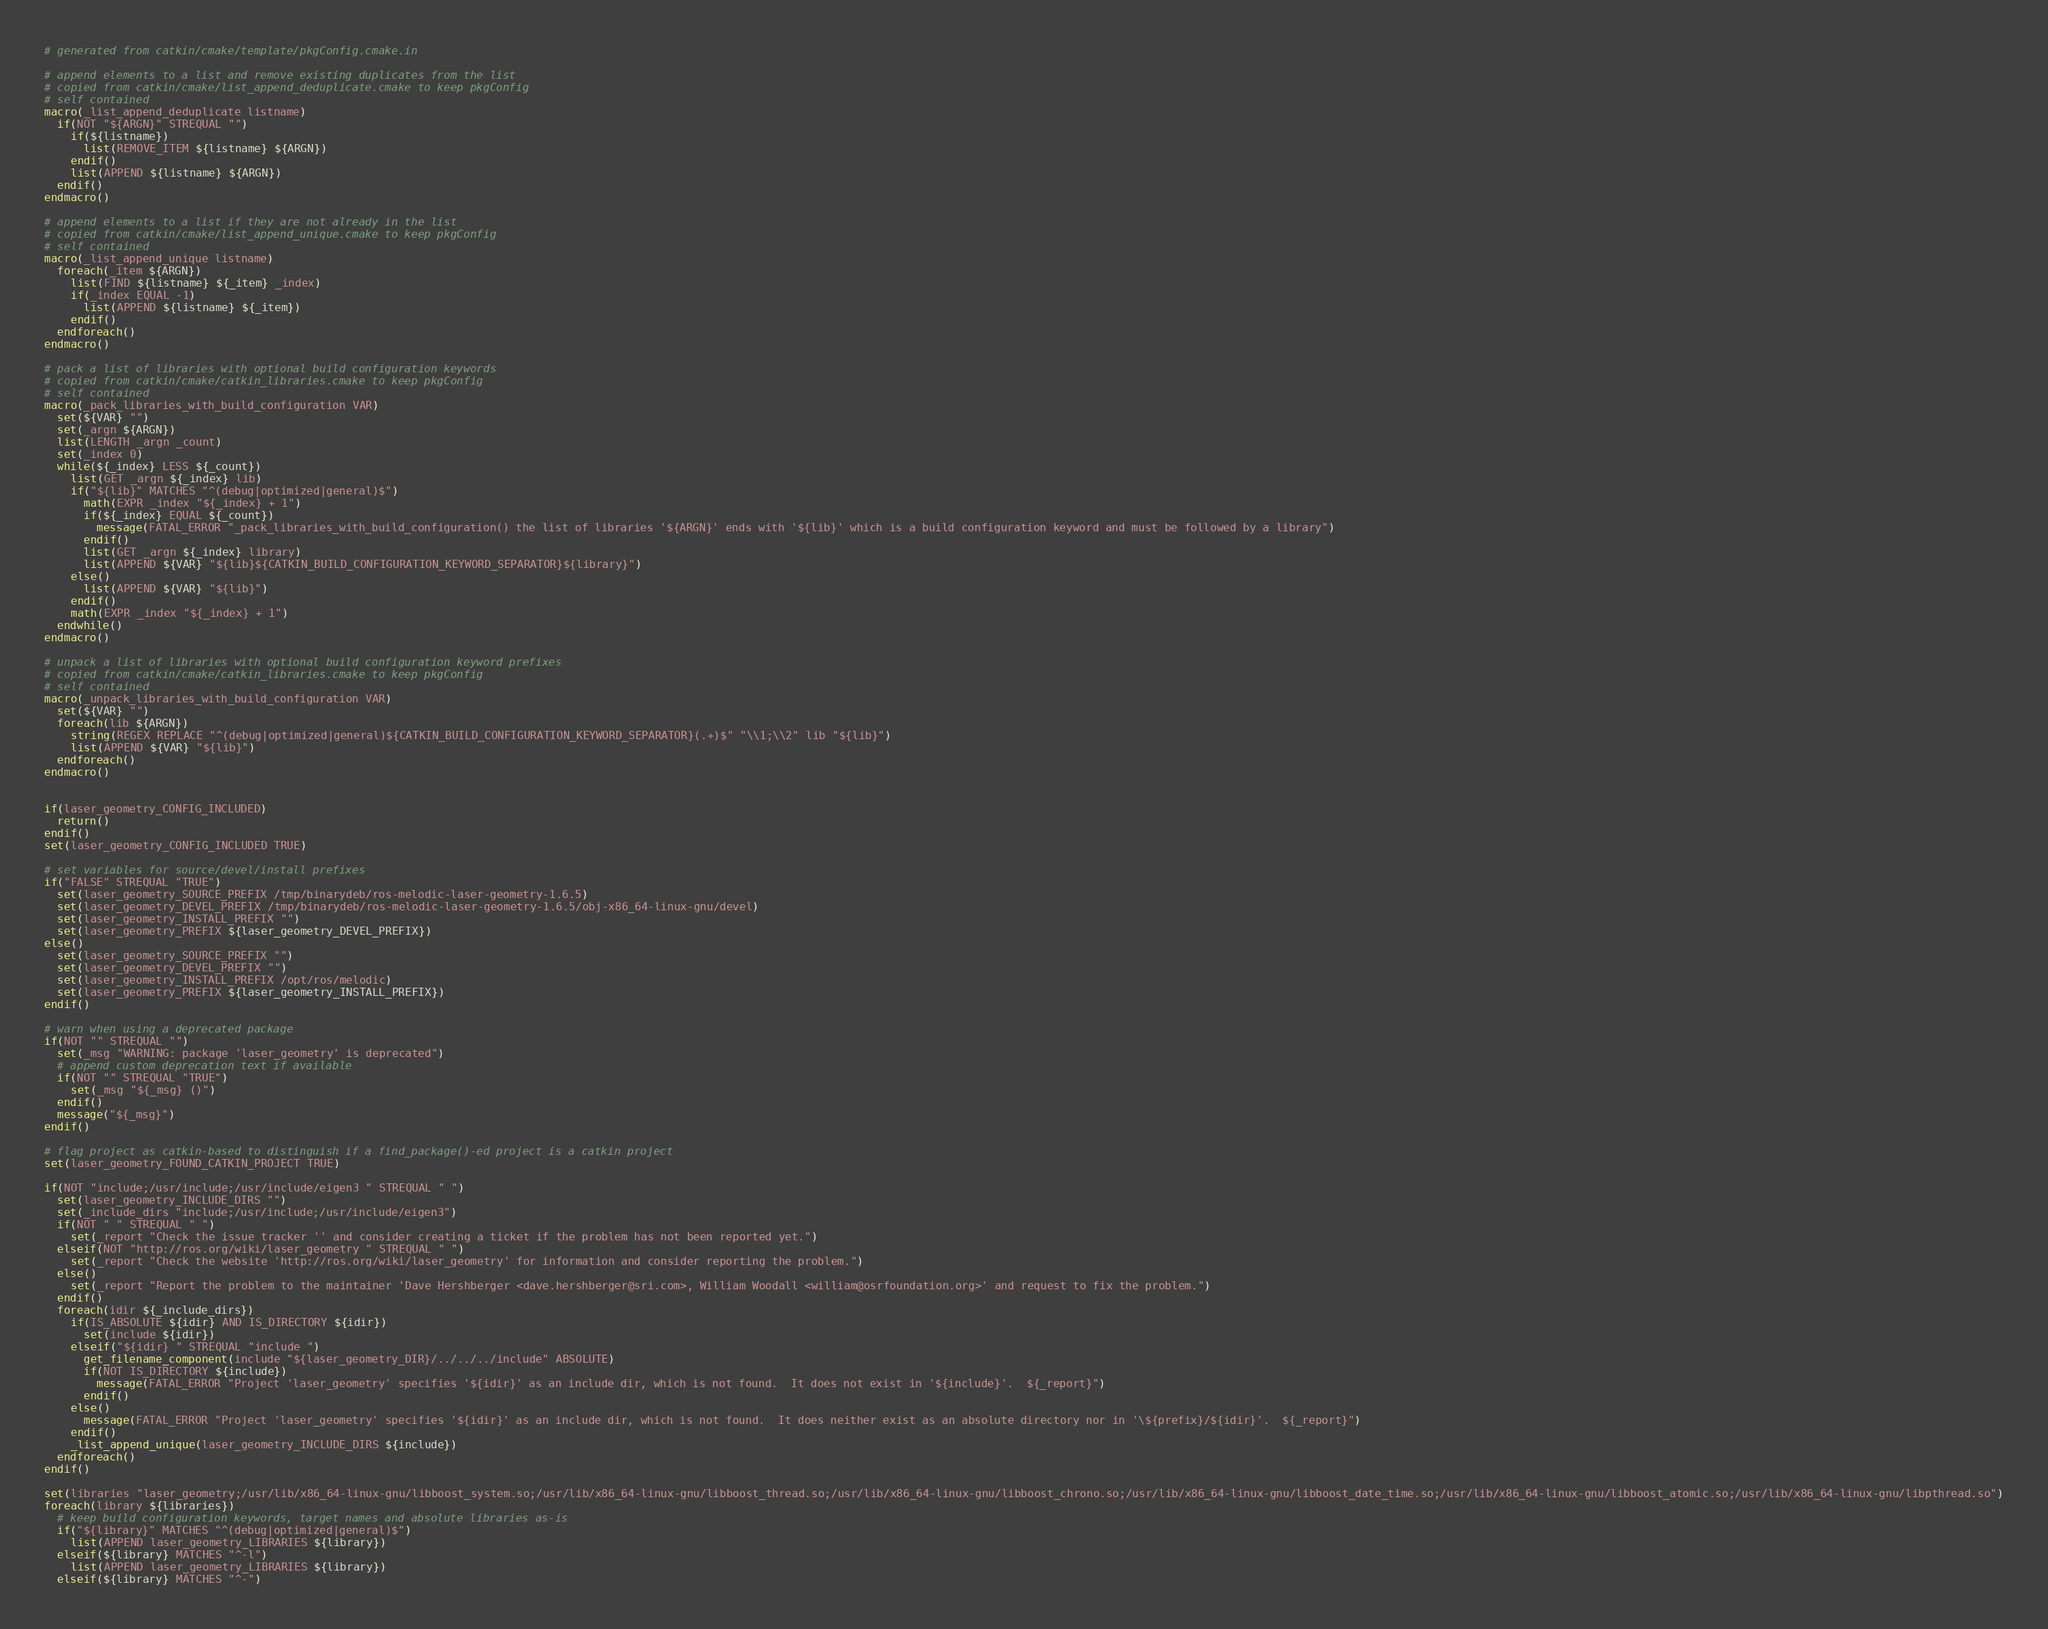<code> <loc_0><loc_0><loc_500><loc_500><_CMake_># generated from catkin/cmake/template/pkgConfig.cmake.in

# append elements to a list and remove existing duplicates from the list
# copied from catkin/cmake/list_append_deduplicate.cmake to keep pkgConfig
# self contained
macro(_list_append_deduplicate listname)
  if(NOT "${ARGN}" STREQUAL "")
    if(${listname})
      list(REMOVE_ITEM ${listname} ${ARGN})
    endif()
    list(APPEND ${listname} ${ARGN})
  endif()
endmacro()

# append elements to a list if they are not already in the list
# copied from catkin/cmake/list_append_unique.cmake to keep pkgConfig
# self contained
macro(_list_append_unique listname)
  foreach(_item ${ARGN})
    list(FIND ${listname} ${_item} _index)
    if(_index EQUAL -1)
      list(APPEND ${listname} ${_item})
    endif()
  endforeach()
endmacro()

# pack a list of libraries with optional build configuration keywords
# copied from catkin/cmake/catkin_libraries.cmake to keep pkgConfig
# self contained
macro(_pack_libraries_with_build_configuration VAR)
  set(${VAR} "")
  set(_argn ${ARGN})
  list(LENGTH _argn _count)
  set(_index 0)
  while(${_index} LESS ${_count})
    list(GET _argn ${_index} lib)
    if("${lib}" MATCHES "^(debug|optimized|general)$")
      math(EXPR _index "${_index} + 1")
      if(${_index} EQUAL ${_count})
        message(FATAL_ERROR "_pack_libraries_with_build_configuration() the list of libraries '${ARGN}' ends with '${lib}' which is a build configuration keyword and must be followed by a library")
      endif()
      list(GET _argn ${_index} library)
      list(APPEND ${VAR} "${lib}${CATKIN_BUILD_CONFIGURATION_KEYWORD_SEPARATOR}${library}")
    else()
      list(APPEND ${VAR} "${lib}")
    endif()
    math(EXPR _index "${_index} + 1")
  endwhile()
endmacro()

# unpack a list of libraries with optional build configuration keyword prefixes
# copied from catkin/cmake/catkin_libraries.cmake to keep pkgConfig
# self contained
macro(_unpack_libraries_with_build_configuration VAR)
  set(${VAR} "")
  foreach(lib ${ARGN})
    string(REGEX REPLACE "^(debug|optimized|general)${CATKIN_BUILD_CONFIGURATION_KEYWORD_SEPARATOR}(.+)$" "\\1;\\2" lib "${lib}")
    list(APPEND ${VAR} "${lib}")
  endforeach()
endmacro()


if(laser_geometry_CONFIG_INCLUDED)
  return()
endif()
set(laser_geometry_CONFIG_INCLUDED TRUE)

# set variables for source/devel/install prefixes
if("FALSE" STREQUAL "TRUE")
  set(laser_geometry_SOURCE_PREFIX /tmp/binarydeb/ros-melodic-laser-geometry-1.6.5)
  set(laser_geometry_DEVEL_PREFIX /tmp/binarydeb/ros-melodic-laser-geometry-1.6.5/obj-x86_64-linux-gnu/devel)
  set(laser_geometry_INSTALL_PREFIX "")
  set(laser_geometry_PREFIX ${laser_geometry_DEVEL_PREFIX})
else()
  set(laser_geometry_SOURCE_PREFIX "")
  set(laser_geometry_DEVEL_PREFIX "")
  set(laser_geometry_INSTALL_PREFIX /opt/ros/melodic)
  set(laser_geometry_PREFIX ${laser_geometry_INSTALL_PREFIX})
endif()

# warn when using a deprecated package
if(NOT "" STREQUAL "")
  set(_msg "WARNING: package 'laser_geometry' is deprecated")
  # append custom deprecation text if available
  if(NOT "" STREQUAL "TRUE")
    set(_msg "${_msg} ()")
  endif()
  message("${_msg}")
endif()

# flag project as catkin-based to distinguish if a find_package()-ed project is a catkin project
set(laser_geometry_FOUND_CATKIN_PROJECT TRUE)

if(NOT "include;/usr/include;/usr/include/eigen3 " STREQUAL " ")
  set(laser_geometry_INCLUDE_DIRS "")
  set(_include_dirs "include;/usr/include;/usr/include/eigen3")
  if(NOT " " STREQUAL " ")
    set(_report "Check the issue tracker '' and consider creating a ticket if the problem has not been reported yet.")
  elseif(NOT "http://ros.org/wiki/laser_geometry " STREQUAL " ")
    set(_report "Check the website 'http://ros.org/wiki/laser_geometry' for information and consider reporting the problem.")
  else()
    set(_report "Report the problem to the maintainer 'Dave Hershberger <dave.hershberger@sri.com>, William Woodall <william@osrfoundation.org>' and request to fix the problem.")
  endif()
  foreach(idir ${_include_dirs})
    if(IS_ABSOLUTE ${idir} AND IS_DIRECTORY ${idir})
      set(include ${idir})
    elseif("${idir} " STREQUAL "include ")
      get_filename_component(include "${laser_geometry_DIR}/../../../include" ABSOLUTE)
      if(NOT IS_DIRECTORY ${include})
        message(FATAL_ERROR "Project 'laser_geometry' specifies '${idir}' as an include dir, which is not found.  It does not exist in '${include}'.  ${_report}")
      endif()
    else()
      message(FATAL_ERROR "Project 'laser_geometry' specifies '${idir}' as an include dir, which is not found.  It does neither exist as an absolute directory nor in '\${prefix}/${idir}'.  ${_report}")
    endif()
    _list_append_unique(laser_geometry_INCLUDE_DIRS ${include})
  endforeach()
endif()

set(libraries "laser_geometry;/usr/lib/x86_64-linux-gnu/libboost_system.so;/usr/lib/x86_64-linux-gnu/libboost_thread.so;/usr/lib/x86_64-linux-gnu/libboost_chrono.so;/usr/lib/x86_64-linux-gnu/libboost_date_time.so;/usr/lib/x86_64-linux-gnu/libboost_atomic.so;/usr/lib/x86_64-linux-gnu/libpthread.so")
foreach(library ${libraries})
  # keep build configuration keywords, target names and absolute libraries as-is
  if("${library}" MATCHES "^(debug|optimized|general)$")
    list(APPEND laser_geometry_LIBRARIES ${library})
  elseif(${library} MATCHES "^-l")
    list(APPEND laser_geometry_LIBRARIES ${library})
  elseif(${library} MATCHES "^-")</code> 